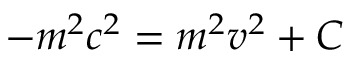Convert formula to latex. <formula><loc_0><loc_0><loc_500><loc_500>- m ^ { 2 } c ^ { 2 } = m ^ { 2 } v ^ { 2 } + C</formula> 